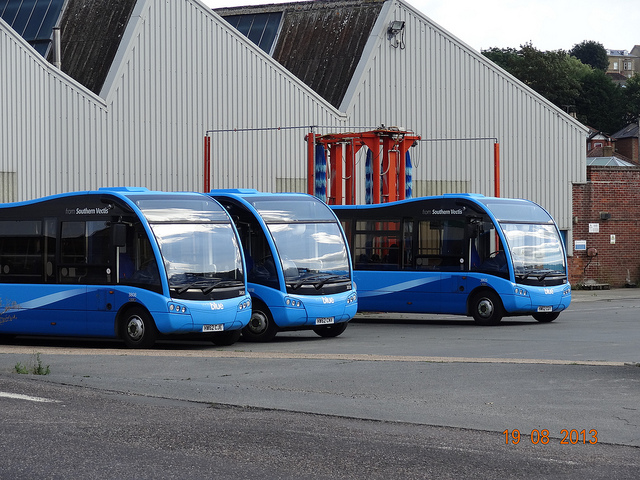Please identify all text content in this image. 19 08 2013 